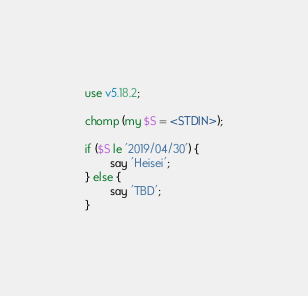<code> <loc_0><loc_0><loc_500><loc_500><_Perl_>use v5.18.2;

chomp (my $S = <STDIN>);

if ($S le '2019/04/30') {
        say 'Heisei';
} else {
        say 'TBD';
}
</code> 